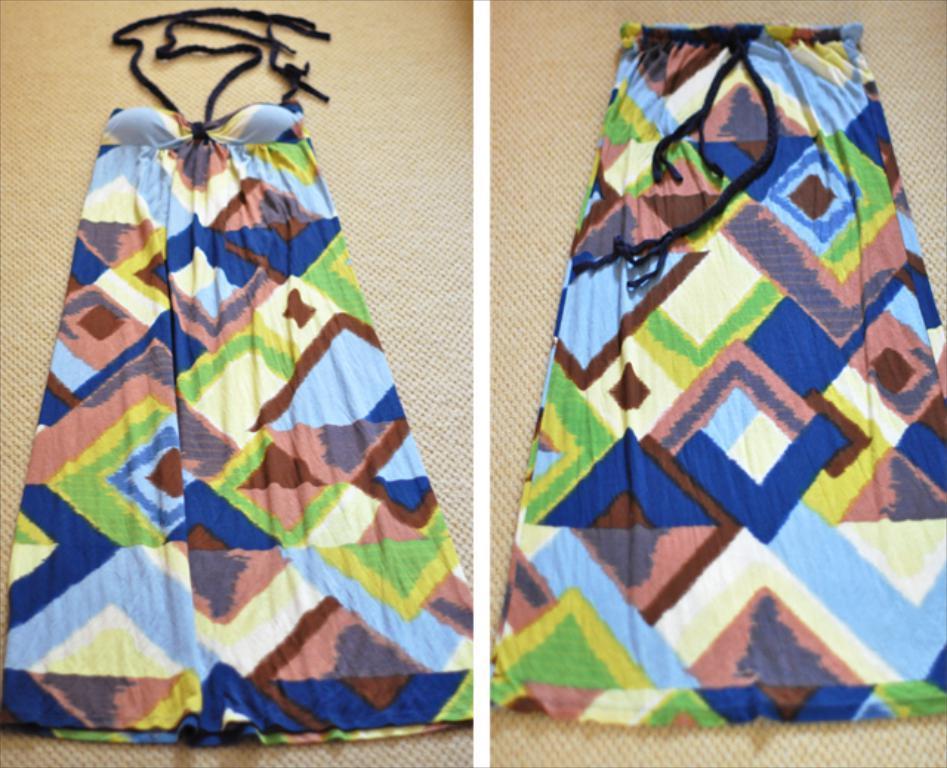In one or two sentences, can you explain what this image depicts? It is a collage picture. On the left side of the image, we can see one colorful dress with black lace on the cream color background. And on the right side of the image, we can see one colorful long skirt with black lace on the cream color background. 